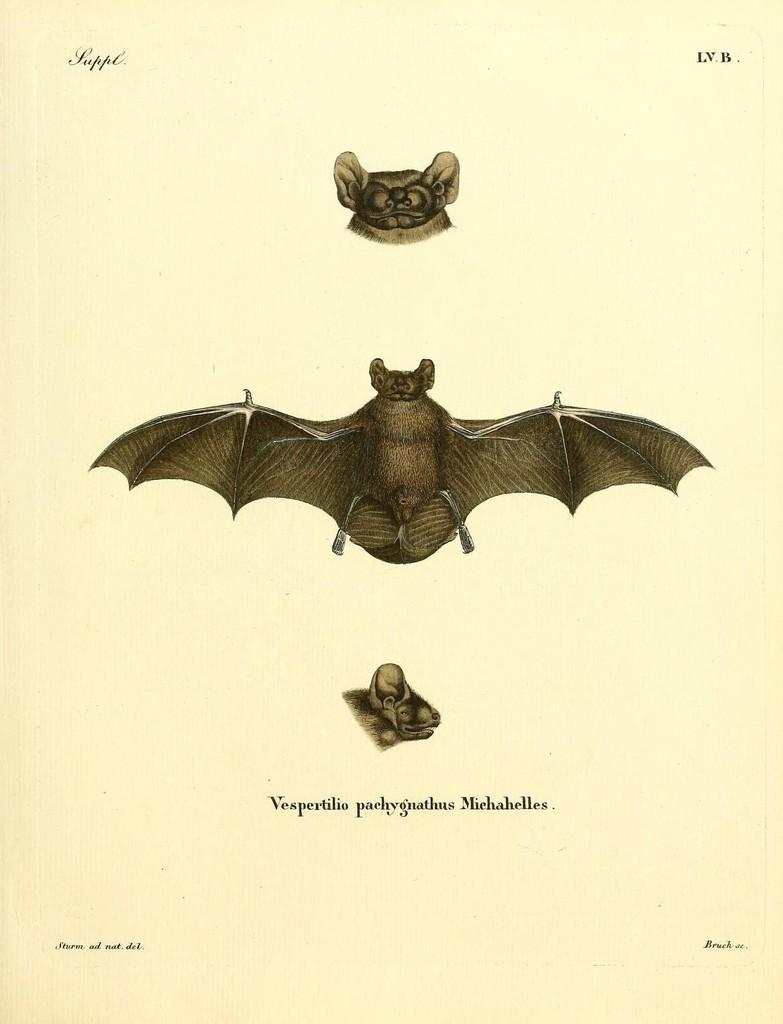Please provide a concise description of this image. In this image, we can see a poster, on that poster we can see a butterfly and an insect. 